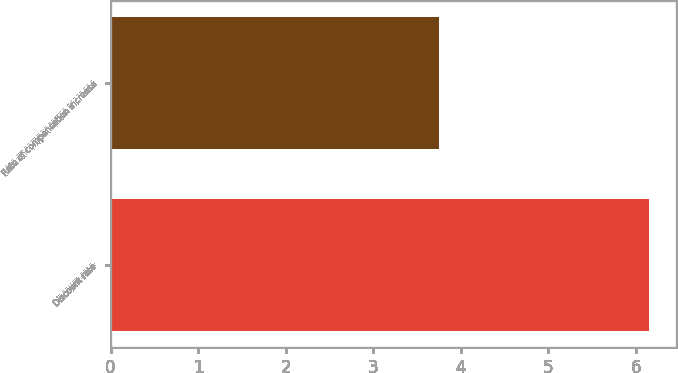<chart> <loc_0><loc_0><loc_500><loc_500><bar_chart><fcel>Discount rate<fcel>Rate of compensation increase<nl><fcel>6.15<fcel>3.75<nl></chart> 